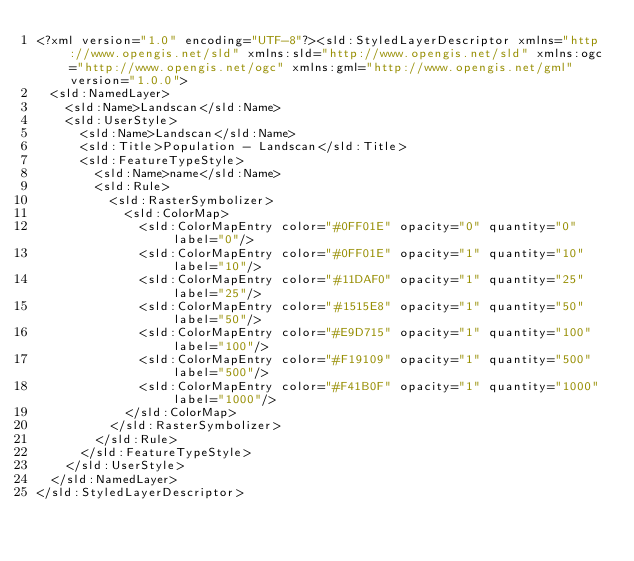<code> <loc_0><loc_0><loc_500><loc_500><_Scheme_><?xml version="1.0" encoding="UTF-8"?><sld:StyledLayerDescriptor xmlns="http://www.opengis.net/sld" xmlns:sld="http://www.opengis.net/sld" xmlns:ogc="http://www.opengis.net/ogc" xmlns:gml="http://www.opengis.net/gml" version="1.0.0">
  <sld:NamedLayer>
    <sld:Name>Landscan</sld:Name>
    <sld:UserStyle>
      <sld:Name>Landscan</sld:Name>
      <sld:Title>Population - Landscan</sld:Title>
      <sld:FeatureTypeStyle>
        <sld:Name>name</sld:Name>
        <sld:Rule>
          <sld:RasterSymbolizer>
            <sld:ColorMap>
              <sld:ColorMapEntry color="#0FF01E" opacity="0" quantity="0" label="0"/>
              <sld:ColorMapEntry color="#0FF01E" opacity="1" quantity="10" label="10"/>
              <sld:ColorMapEntry color="#11DAF0" opacity="1" quantity="25" label="25"/>
              <sld:ColorMapEntry color="#1515E8" opacity="1" quantity="50" label="50"/>
              <sld:ColorMapEntry color="#E9D715" opacity="1" quantity="100" label="100"/>
              <sld:ColorMapEntry color="#F19109" opacity="1" quantity="500" label="500"/>
              <sld:ColorMapEntry color="#F41B0F" opacity="1" quantity="1000" label="1000"/>
            </sld:ColorMap>
          </sld:RasterSymbolizer>
        </sld:Rule>
      </sld:FeatureTypeStyle>
    </sld:UserStyle>
  </sld:NamedLayer>
</sld:StyledLayerDescriptor>
</code> 